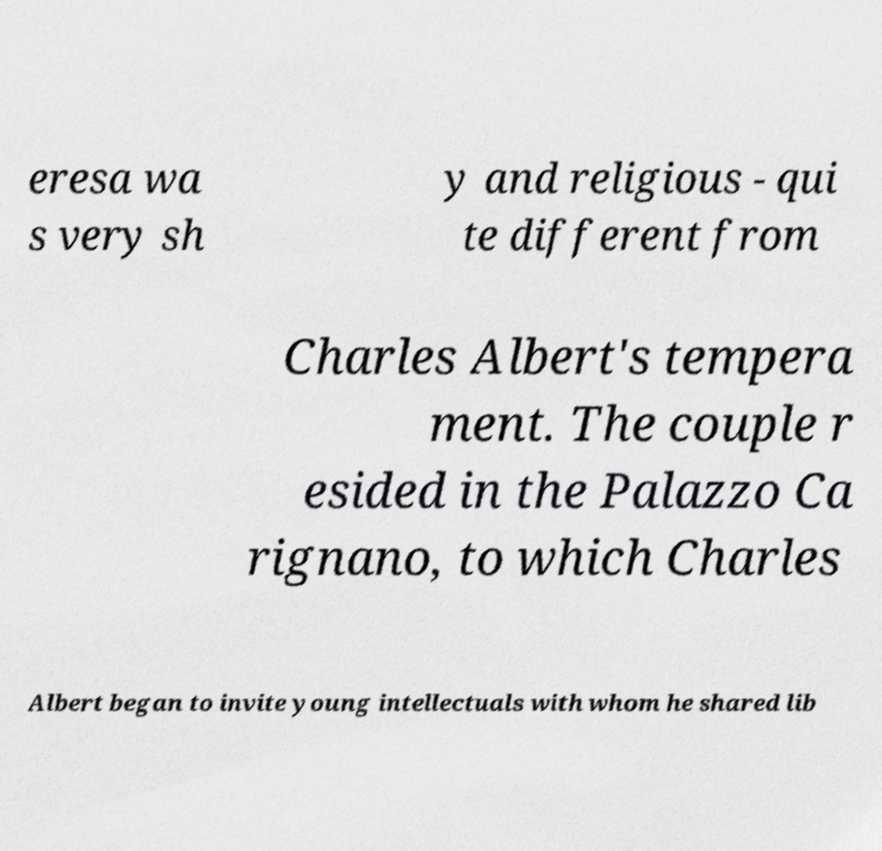Could you assist in decoding the text presented in this image and type it out clearly? eresa wa s very sh y and religious - qui te different from Charles Albert's tempera ment. The couple r esided in the Palazzo Ca rignano, to which Charles Albert began to invite young intellectuals with whom he shared lib 